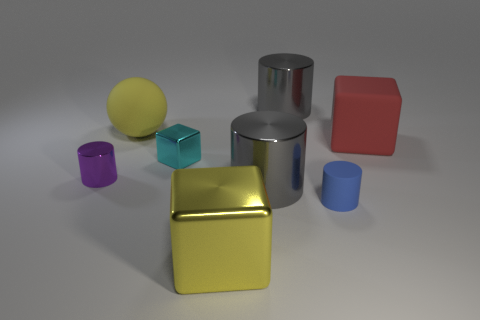Subtract 1 cylinders. How many cylinders are left? 3 Add 1 tiny rubber balls. How many objects exist? 9 Subtract all blocks. How many objects are left? 5 Subtract all big cyan metal blocks. Subtract all large red matte blocks. How many objects are left? 7 Add 7 small shiny cylinders. How many small shiny cylinders are left? 8 Add 4 red cylinders. How many red cylinders exist? 4 Subtract 0 red balls. How many objects are left? 8 